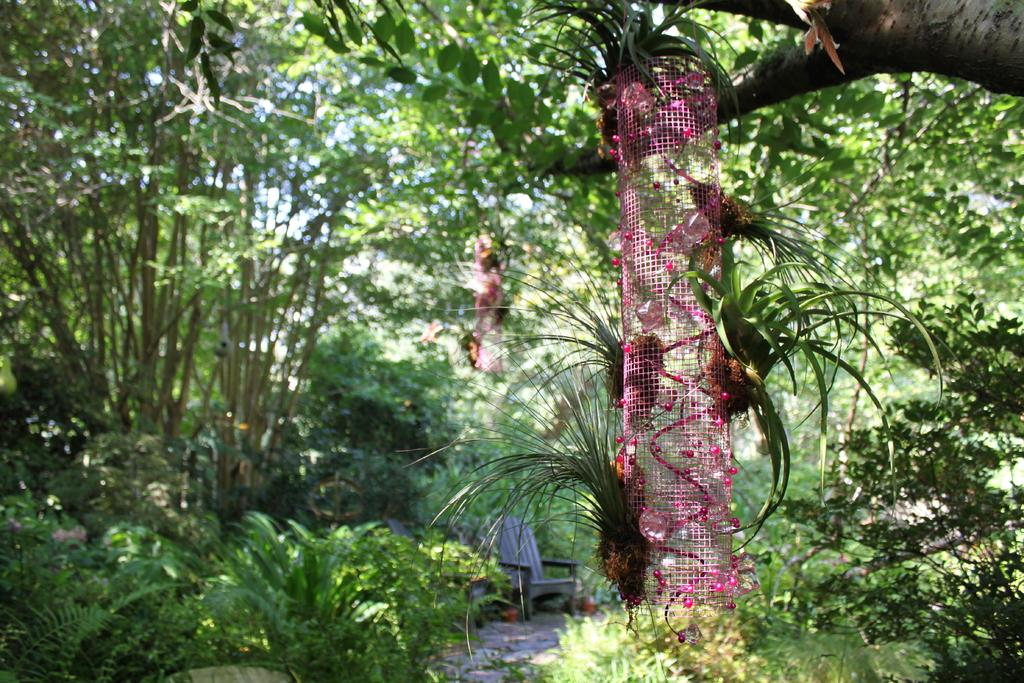What shape is the net in the image? The net in the image is in the shape of a cylinder. What can be seen in the background of the image? There are trees in the background of the image. What type of furniture is at the bottom of the image? There is a chair at the bottom of the image. What type of tin can be seen in the image? There is no tin present in the image. 